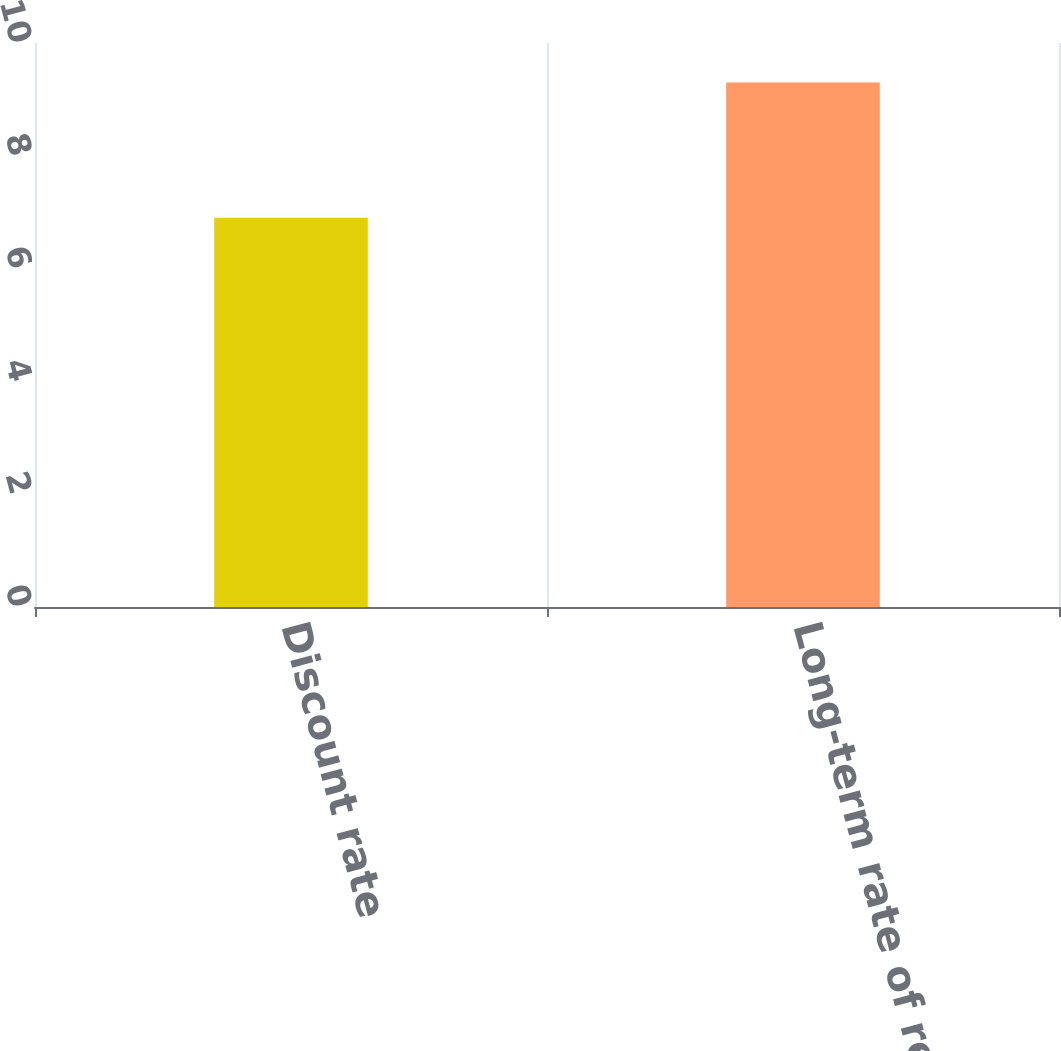Convert chart. <chart><loc_0><loc_0><loc_500><loc_500><bar_chart><fcel>Discount rate<fcel>Long-term rate of return on<nl><fcel>6.9<fcel>9.3<nl></chart> 